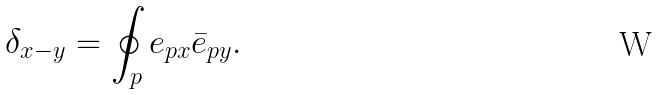<formula> <loc_0><loc_0><loc_500><loc_500>\delta _ { x - y } = \oint _ { p } e _ { p x } \bar { e } _ { p y } .</formula> 